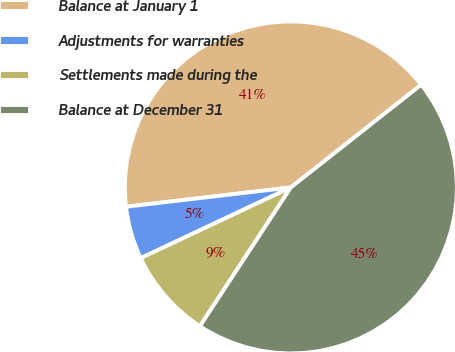Convert chart to OTSL. <chart><loc_0><loc_0><loc_500><loc_500><pie_chart><fcel>Balance at January 1<fcel>Adjustments for warranties<fcel>Settlements made during the<fcel>Balance at December 31<nl><fcel>41.24%<fcel>5.15%<fcel>8.76%<fcel>44.85%<nl></chart> 